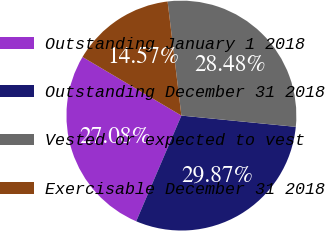Convert chart. <chart><loc_0><loc_0><loc_500><loc_500><pie_chart><fcel>Outstanding January 1 2018<fcel>Outstanding December 31 2018<fcel>Vested or expected to vest<fcel>Exercisable December 31 2018<nl><fcel>27.08%<fcel>29.87%<fcel>28.48%<fcel>14.57%<nl></chart> 